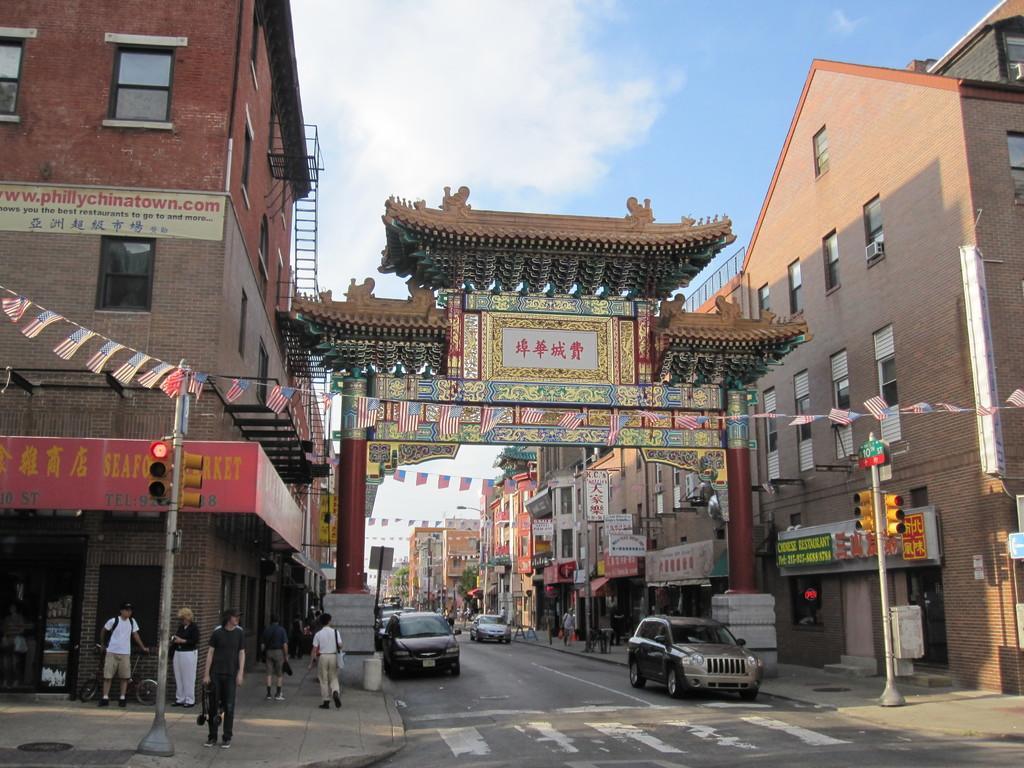In one or two sentences, can you explain what this image depicts? In this picture I can see many buildings, flags, street lights and tree. In the bottom left there is a man who is wearing black dress. He is standing near to the pole and traffic signals. Behind him there are two persons were standing near to the door. Beside them there are two persons were standing on the street walk. At the bottom there is a grey color car which is parked near to the pole and zebra crossing. In the background I can see the sign boards, trees, fencing, cars, poles and other objects. At the top I can see the sky and clouds. 